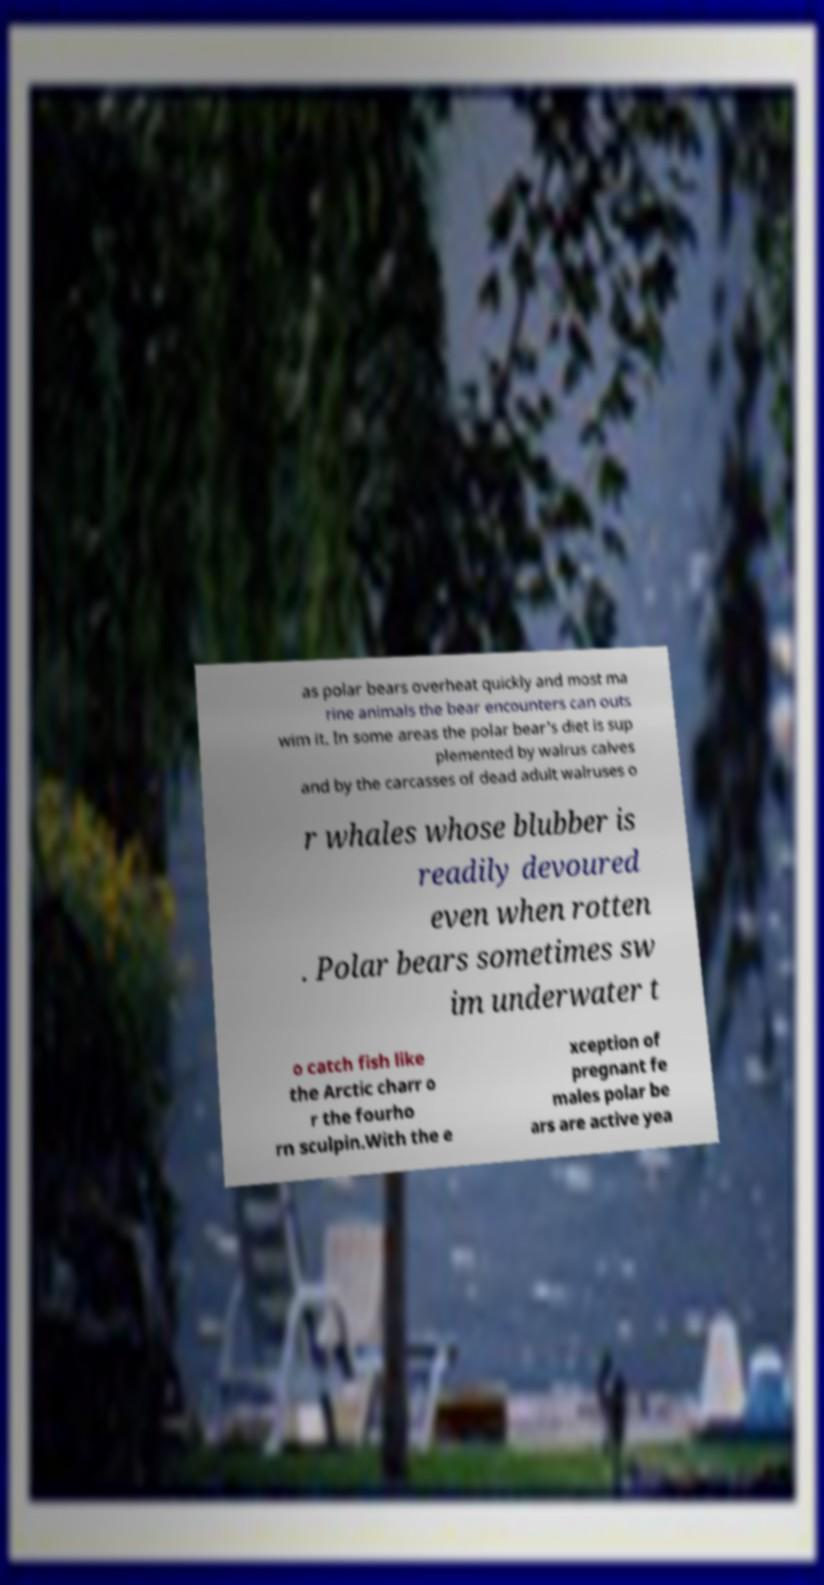Can you accurately transcribe the text from the provided image for me? as polar bears overheat quickly and most ma rine animals the bear encounters can outs wim it. In some areas the polar bear's diet is sup plemented by walrus calves and by the carcasses of dead adult walruses o r whales whose blubber is readily devoured even when rotten . Polar bears sometimes sw im underwater t o catch fish like the Arctic charr o r the fourho rn sculpin.With the e xception of pregnant fe males polar be ars are active yea 